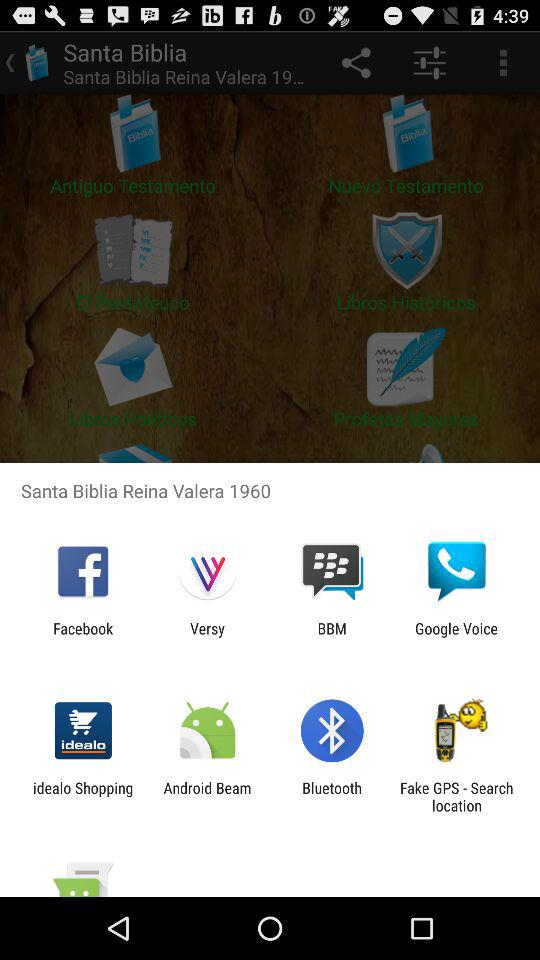From which app we can share? You can share it through "Facebook", "Versy", "BBM", "Google Voice", "idealo Shopping", "Android Beam", "Bluetooth" and "Fake GPS - Search location". 